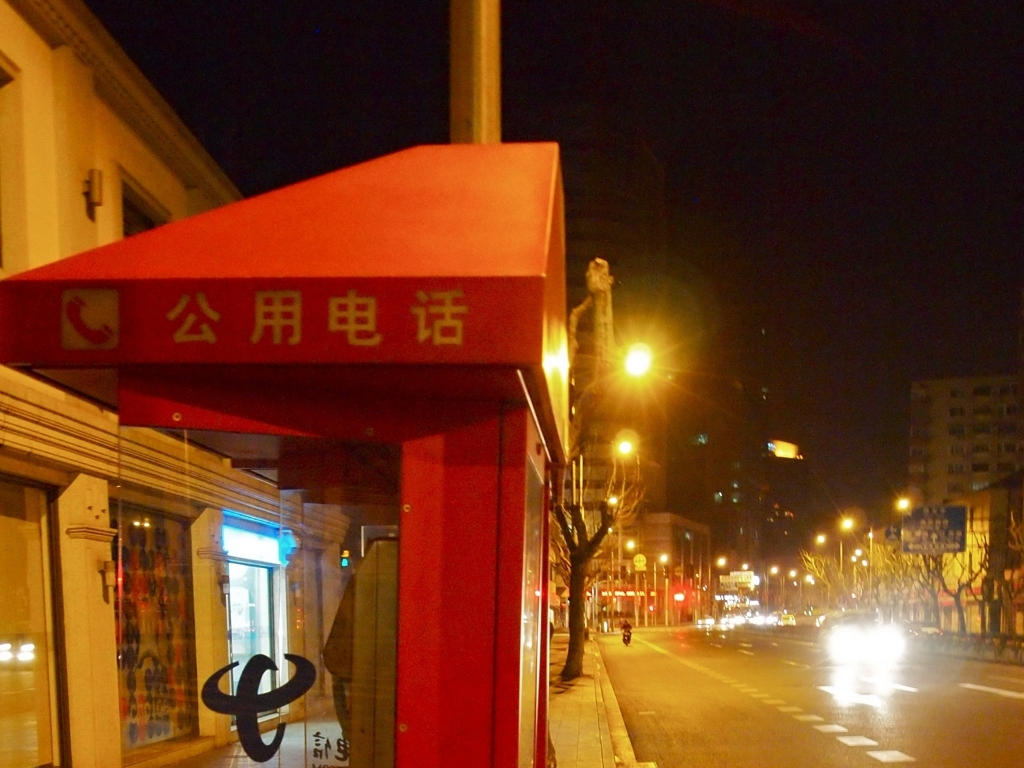Is there any loss of details in the dark areas? Indeed, the image exhibits loss of detail in the shadows and darker areas, particularly noticeable around the edges of the awning and the spaces beneath it, where the ambient light from the surroundings does not adequately illuminate the details. 